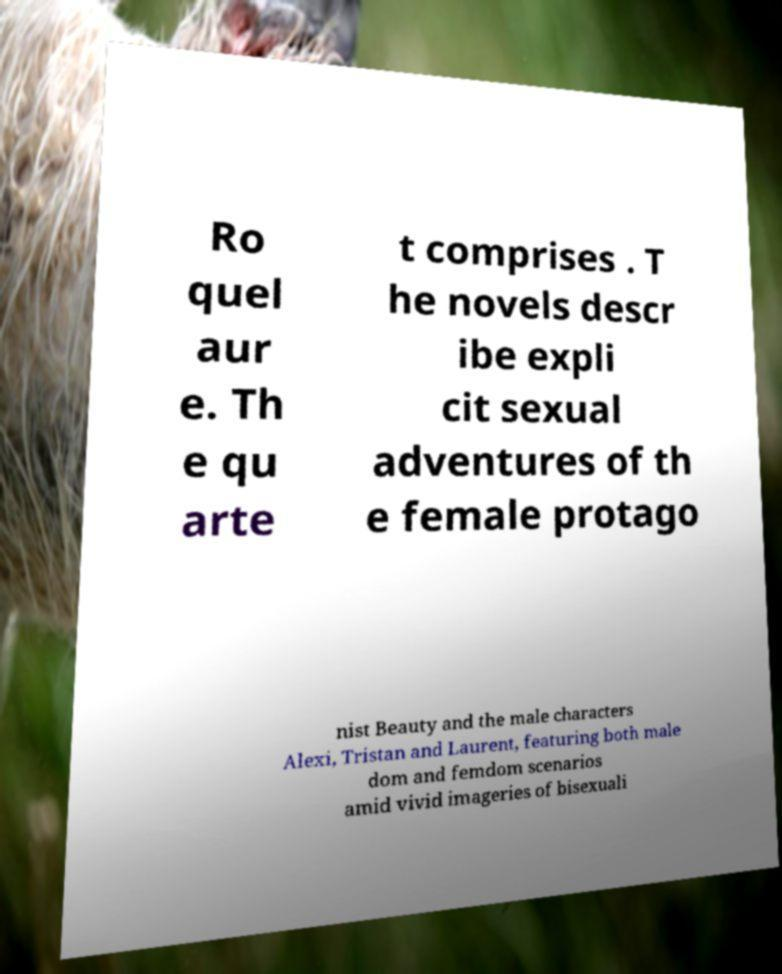I need the written content from this picture converted into text. Can you do that? Ro quel aur e. Th e qu arte t comprises . T he novels descr ibe expli cit sexual adventures of th e female protago nist Beauty and the male characters Alexi, Tristan and Laurent, featuring both male dom and femdom scenarios amid vivid imageries of bisexuali 